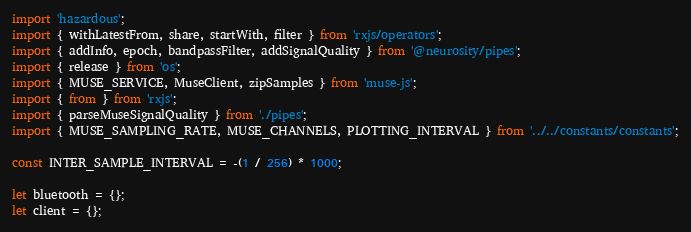<code> <loc_0><loc_0><loc_500><loc_500><_JavaScript_>import 'hazardous';
import { withLatestFrom, share, startWith, filter } from 'rxjs/operators';
import { addInfo, epoch, bandpassFilter, addSignalQuality } from '@neurosity/pipes';
import { release } from 'os';
import { MUSE_SERVICE, MuseClient, zipSamples } from 'muse-js';
import { from } from 'rxjs';
import { parseMuseSignalQuality } from './pipes';
import { MUSE_SAMPLING_RATE, MUSE_CHANNELS, PLOTTING_INTERVAL } from '../../constants/constants';

const INTER_SAMPLE_INTERVAL = -(1 / 256) * 1000;

let bluetooth = {};
let client = {};</code> 